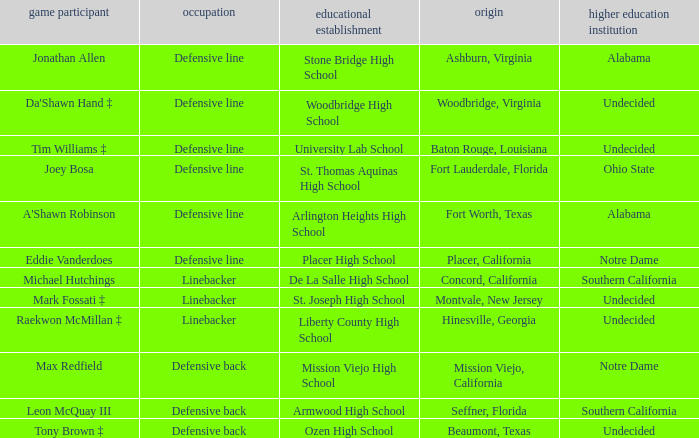What is the position of the player from Beaumont, Texas? Defensive back. 